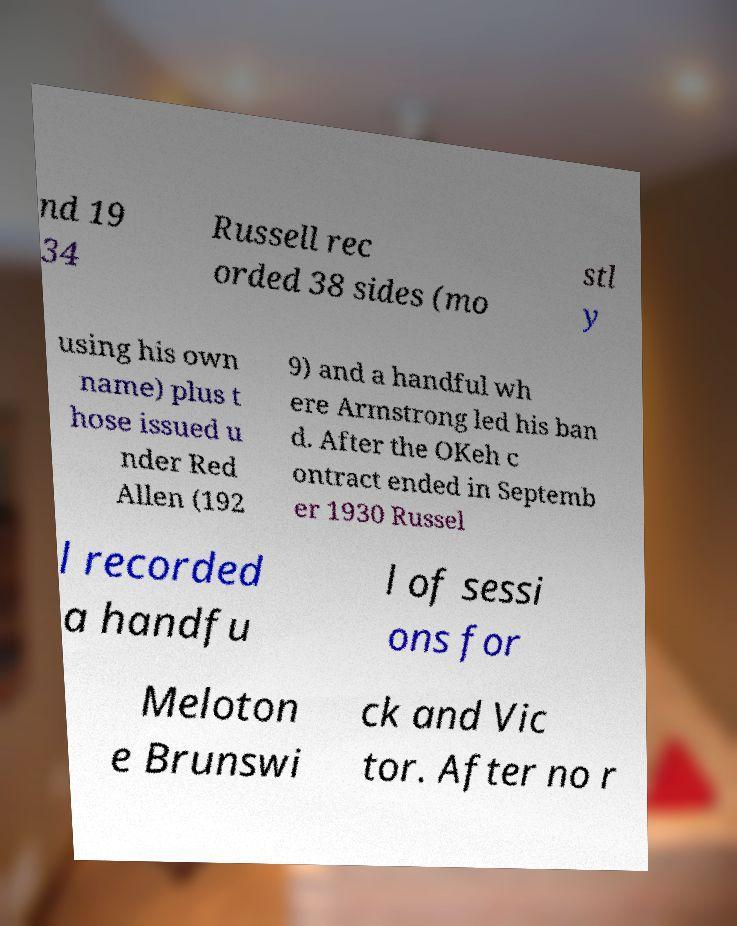Could you assist in decoding the text presented in this image and type it out clearly? nd 19 34 Russell rec orded 38 sides (mo stl y using his own name) plus t hose issued u nder Red Allen (192 9) and a handful wh ere Armstrong led his ban d. After the OKeh c ontract ended in Septemb er 1930 Russel l recorded a handfu l of sessi ons for Meloton e Brunswi ck and Vic tor. After no r 